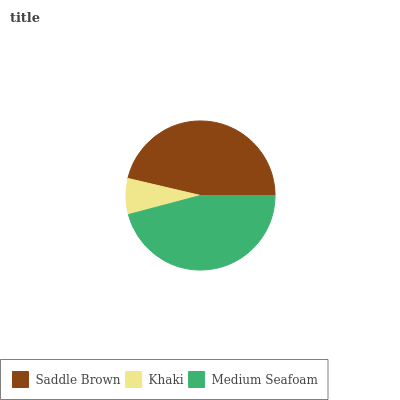Is Khaki the minimum?
Answer yes or no. Yes. Is Saddle Brown the maximum?
Answer yes or no. Yes. Is Medium Seafoam the minimum?
Answer yes or no. No. Is Medium Seafoam the maximum?
Answer yes or no. No. Is Medium Seafoam greater than Khaki?
Answer yes or no. Yes. Is Khaki less than Medium Seafoam?
Answer yes or no. Yes. Is Khaki greater than Medium Seafoam?
Answer yes or no. No. Is Medium Seafoam less than Khaki?
Answer yes or no. No. Is Medium Seafoam the high median?
Answer yes or no. Yes. Is Medium Seafoam the low median?
Answer yes or no. Yes. Is Saddle Brown the high median?
Answer yes or no. No. Is Saddle Brown the low median?
Answer yes or no. No. 